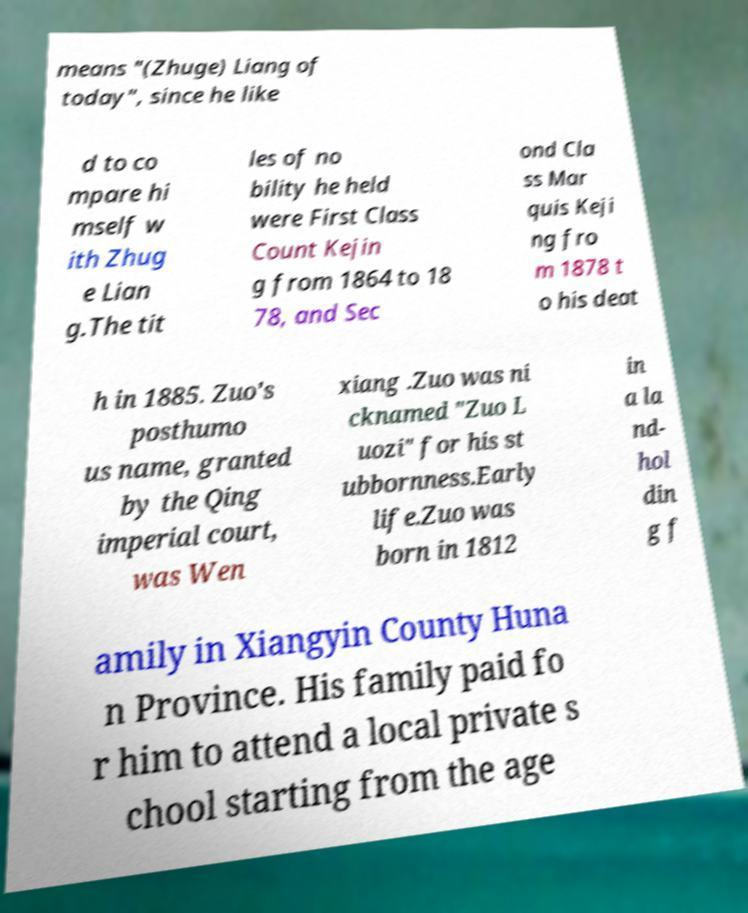There's text embedded in this image that I need extracted. Can you transcribe it verbatim? means "(Zhuge) Liang of today", since he like d to co mpare hi mself w ith Zhug e Lian g.The tit les of no bility he held were First Class Count Kejin g from 1864 to 18 78, and Sec ond Cla ss Mar quis Keji ng fro m 1878 t o his deat h in 1885. Zuo's posthumo us name, granted by the Qing imperial court, was Wen xiang .Zuo was ni cknamed "Zuo L uozi" for his st ubbornness.Early life.Zuo was born in 1812 in a la nd- hol din g f amily in Xiangyin County Huna n Province. His family paid fo r him to attend a local private s chool starting from the age 